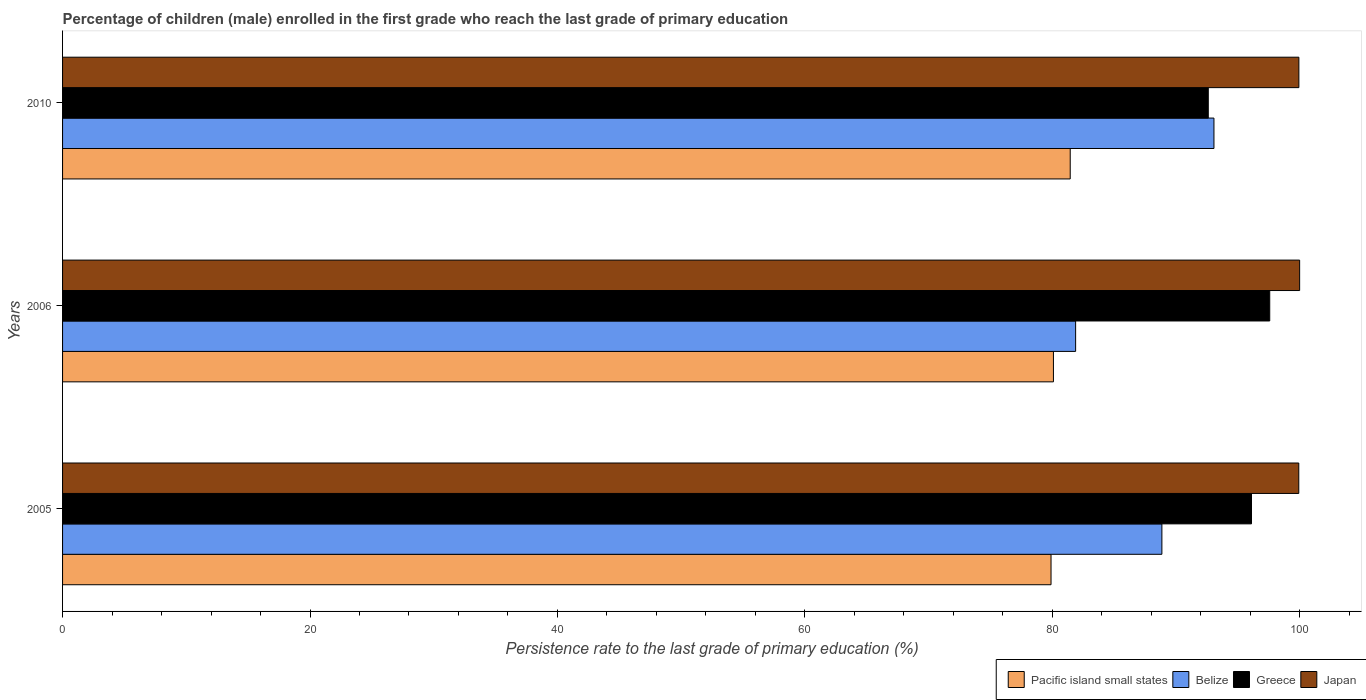How many different coloured bars are there?
Offer a terse response. 4. How many groups of bars are there?
Offer a terse response. 3. Are the number of bars on each tick of the Y-axis equal?
Make the answer very short. Yes. How many bars are there on the 2nd tick from the top?
Provide a short and direct response. 4. How many bars are there on the 1st tick from the bottom?
Your answer should be compact. 4. In how many cases, is the number of bars for a given year not equal to the number of legend labels?
Offer a very short reply. 0. What is the persistence rate of children in Greece in 2006?
Give a very brief answer. 97.57. Across all years, what is the maximum persistence rate of children in Japan?
Your answer should be very brief. 99.99. Across all years, what is the minimum persistence rate of children in Greece?
Offer a terse response. 92.6. In which year was the persistence rate of children in Pacific island small states maximum?
Give a very brief answer. 2010. What is the total persistence rate of children in Belize in the graph?
Your answer should be very brief. 263.8. What is the difference between the persistence rate of children in Japan in 2005 and that in 2010?
Your answer should be very brief. -0.01. What is the difference between the persistence rate of children in Pacific island small states in 2006 and the persistence rate of children in Japan in 2010?
Give a very brief answer. -19.84. What is the average persistence rate of children in Belize per year?
Make the answer very short. 87.93. In the year 2010, what is the difference between the persistence rate of children in Japan and persistence rate of children in Belize?
Give a very brief answer. 6.86. What is the ratio of the persistence rate of children in Japan in 2005 to that in 2006?
Provide a succinct answer. 1. Is the persistence rate of children in Pacific island small states in 2005 less than that in 2006?
Your answer should be very brief. Yes. Is the difference between the persistence rate of children in Japan in 2005 and 2006 greater than the difference between the persistence rate of children in Belize in 2005 and 2006?
Provide a succinct answer. No. What is the difference between the highest and the second highest persistence rate of children in Japan?
Keep it short and to the point. 0.06. What is the difference between the highest and the lowest persistence rate of children in Greece?
Your response must be concise. 4.97. Is the sum of the persistence rate of children in Pacific island small states in 2005 and 2006 greater than the maximum persistence rate of children in Belize across all years?
Provide a short and direct response. Yes. Is it the case that in every year, the sum of the persistence rate of children in Belize and persistence rate of children in Japan is greater than the sum of persistence rate of children in Greece and persistence rate of children in Pacific island small states?
Make the answer very short. Yes. What does the 1st bar from the top in 2006 represents?
Provide a succinct answer. Japan. What does the 3rd bar from the bottom in 2010 represents?
Your answer should be very brief. Greece. How many bars are there?
Your response must be concise. 12. Does the graph contain any zero values?
Keep it short and to the point. No. How are the legend labels stacked?
Make the answer very short. Horizontal. What is the title of the graph?
Your response must be concise. Percentage of children (male) enrolled in the first grade who reach the last grade of primary education. Does "Korea (Democratic)" appear as one of the legend labels in the graph?
Provide a short and direct response. No. What is the label or title of the X-axis?
Your response must be concise. Persistence rate to the last grade of primary education (%). What is the Persistence rate to the last grade of primary education (%) of Pacific island small states in 2005?
Ensure brevity in your answer.  79.89. What is the Persistence rate to the last grade of primary education (%) of Belize in 2005?
Ensure brevity in your answer.  88.85. What is the Persistence rate to the last grade of primary education (%) of Greece in 2005?
Your answer should be compact. 96.1. What is the Persistence rate to the last grade of primary education (%) of Japan in 2005?
Your response must be concise. 99.92. What is the Persistence rate to the last grade of primary education (%) of Pacific island small states in 2006?
Make the answer very short. 80.09. What is the Persistence rate to the last grade of primary education (%) in Belize in 2006?
Keep it short and to the point. 81.88. What is the Persistence rate to the last grade of primary education (%) of Greece in 2006?
Provide a succinct answer. 97.57. What is the Persistence rate to the last grade of primary education (%) in Japan in 2006?
Provide a short and direct response. 99.99. What is the Persistence rate to the last grade of primary education (%) in Pacific island small states in 2010?
Offer a terse response. 81.44. What is the Persistence rate to the last grade of primary education (%) in Belize in 2010?
Ensure brevity in your answer.  93.06. What is the Persistence rate to the last grade of primary education (%) in Greece in 2010?
Provide a succinct answer. 92.6. What is the Persistence rate to the last grade of primary education (%) of Japan in 2010?
Your answer should be very brief. 99.93. Across all years, what is the maximum Persistence rate to the last grade of primary education (%) of Pacific island small states?
Provide a succinct answer. 81.44. Across all years, what is the maximum Persistence rate to the last grade of primary education (%) in Belize?
Provide a succinct answer. 93.06. Across all years, what is the maximum Persistence rate to the last grade of primary education (%) in Greece?
Offer a terse response. 97.57. Across all years, what is the maximum Persistence rate to the last grade of primary education (%) of Japan?
Offer a terse response. 99.99. Across all years, what is the minimum Persistence rate to the last grade of primary education (%) in Pacific island small states?
Provide a succinct answer. 79.89. Across all years, what is the minimum Persistence rate to the last grade of primary education (%) of Belize?
Your response must be concise. 81.88. Across all years, what is the minimum Persistence rate to the last grade of primary education (%) in Greece?
Your response must be concise. 92.6. Across all years, what is the minimum Persistence rate to the last grade of primary education (%) in Japan?
Offer a terse response. 99.92. What is the total Persistence rate to the last grade of primary education (%) in Pacific island small states in the graph?
Offer a terse response. 241.43. What is the total Persistence rate to the last grade of primary education (%) of Belize in the graph?
Provide a short and direct response. 263.8. What is the total Persistence rate to the last grade of primary education (%) in Greece in the graph?
Ensure brevity in your answer.  286.27. What is the total Persistence rate to the last grade of primary education (%) of Japan in the graph?
Your response must be concise. 299.83. What is the difference between the Persistence rate to the last grade of primary education (%) of Pacific island small states in 2005 and that in 2006?
Provide a short and direct response. -0.19. What is the difference between the Persistence rate to the last grade of primary education (%) of Belize in 2005 and that in 2006?
Your answer should be compact. 6.97. What is the difference between the Persistence rate to the last grade of primary education (%) of Greece in 2005 and that in 2006?
Provide a succinct answer. -1.47. What is the difference between the Persistence rate to the last grade of primary education (%) in Japan in 2005 and that in 2006?
Keep it short and to the point. -0.07. What is the difference between the Persistence rate to the last grade of primary education (%) in Pacific island small states in 2005 and that in 2010?
Make the answer very short. -1.55. What is the difference between the Persistence rate to the last grade of primary education (%) of Belize in 2005 and that in 2010?
Make the answer very short. -4.21. What is the difference between the Persistence rate to the last grade of primary education (%) of Greece in 2005 and that in 2010?
Your answer should be very brief. 3.49. What is the difference between the Persistence rate to the last grade of primary education (%) of Japan in 2005 and that in 2010?
Provide a succinct answer. -0.01. What is the difference between the Persistence rate to the last grade of primary education (%) of Pacific island small states in 2006 and that in 2010?
Your response must be concise. -1.36. What is the difference between the Persistence rate to the last grade of primary education (%) in Belize in 2006 and that in 2010?
Your response must be concise. -11.18. What is the difference between the Persistence rate to the last grade of primary education (%) in Greece in 2006 and that in 2010?
Offer a terse response. 4.97. What is the difference between the Persistence rate to the last grade of primary education (%) of Japan in 2006 and that in 2010?
Offer a terse response. 0.06. What is the difference between the Persistence rate to the last grade of primary education (%) in Pacific island small states in 2005 and the Persistence rate to the last grade of primary education (%) in Belize in 2006?
Provide a succinct answer. -1.99. What is the difference between the Persistence rate to the last grade of primary education (%) in Pacific island small states in 2005 and the Persistence rate to the last grade of primary education (%) in Greece in 2006?
Provide a succinct answer. -17.68. What is the difference between the Persistence rate to the last grade of primary education (%) in Pacific island small states in 2005 and the Persistence rate to the last grade of primary education (%) in Japan in 2006?
Give a very brief answer. -20.09. What is the difference between the Persistence rate to the last grade of primary education (%) of Belize in 2005 and the Persistence rate to the last grade of primary education (%) of Greece in 2006?
Offer a very short reply. -8.72. What is the difference between the Persistence rate to the last grade of primary education (%) of Belize in 2005 and the Persistence rate to the last grade of primary education (%) of Japan in 2006?
Offer a terse response. -11.13. What is the difference between the Persistence rate to the last grade of primary education (%) of Greece in 2005 and the Persistence rate to the last grade of primary education (%) of Japan in 2006?
Ensure brevity in your answer.  -3.89. What is the difference between the Persistence rate to the last grade of primary education (%) of Pacific island small states in 2005 and the Persistence rate to the last grade of primary education (%) of Belize in 2010?
Your response must be concise. -13.17. What is the difference between the Persistence rate to the last grade of primary education (%) in Pacific island small states in 2005 and the Persistence rate to the last grade of primary education (%) in Greece in 2010?
Keep it short and to the point. -12.71. What is the difference between the Persistence rate to the last grade of primary education (%) of Pacific island small states in 2005 and the Persistence rate to the last grade of primary education (%) of Japan in 2010?
Keep it short and to the point. -20.03. What is the difference between the Persistence rate to the last grade of primary education (%) of Belize in 2005 and the Persistence rate to the last grade of primary education (%) of Greece in 2010?
Offer a very short reply. -3.75. What is the difference between the Persistence rate to the last grade of primary education (%) of Belize in 2005 and the Persistence rate to the last grade of primary education (%) of Japan in 2010?
Provide a short and direct response. -11.07. What is the difference between the Persistence rate to the last grade of primary education (%) of Greece in 2005 and the Persistence rate to the last grade of primary education (%) of Japan in 2010?
Ensure brevity in your answer.  -3.83. What is the difference between the Persistence rate to the last grade of primary education (%) of Pacific island small states in 2006 and the Persistence rate to the last grade of primary education (%) of Belize in 2010?
Offer a terse response. -12.97. What is the difference between the Persistence rate to the last grade of primary education (%) in Pacific island small states in 2006 and the Persistence rate to the last grade of primary education (%) in Greece in 2010?
Make the answer very short. -12.51. What is the difference between the Persistence rate to the last grade of primary education (%) in Pacific island small states in 2006 and the Persistence rate to the last grade of primary education (%) in Japan in 2010?
Provide a succinct answer. -19.84. What is the difference between the Persistence rate to the last grade of primary education (%) of Belize in 2006 and the Persistence rate to the last grade of primary education (%) of Greece in 2010?
Keep it short and to the point. -10.72. What is the difference between the Persistence rate to the last grade of primary education (%) in Belize in 2006 and the Persistence rate to the last grade of primary education (%) in Japan in 2010?
Provide a short and direct response. -18.04. What is the difference between the Persistence rate to the last grade of primary education (%) in Greece in 2006 and the Persistence rate to the last grade of primary education (%) in Japan in 2010?
Your answer should be very brief. -2.36. What is the average Persistence rate to the last grade of primary education (%) of Pacific island small states per year?
Your answer should be very brief. 80.48. What is the average Persistence rate to the last grade of primary education (%) in Belize per year?
Your response must be concise. 87.93. What is the average Persistence rate to the last grade of primary education (%) in Greece per year?
Your answer should be very brief. 95.42. What is the average Persistence rate to the last grade of primary education (%) in Japan per year?
Offer a very short reply. 99.94. In the year 2005, what is the difference between the Persistence rate to the last grade of primary education (%) in Pacific island small states and Persistence rate to the last grade of primary education (%) in Belize?
Keep it short and to the point. -8.96. In the year 2005, what is the difference between the Persistence rate to the last grade of primary education (%) in Pacific island small states and Persistence rate to the last grade of primary education (%) in Greece?
Provide a short and direct response. -16.2. In the year 2005, what is the difference between the Persistence rate to the last grade of primary education (%) of Pacific island small states and Persistence rate to the last grade of primary education (%) of Japan?
Your answer should be compact. -20.02. In the year 2005, what is the difference between the Persistence rate to the last grade of primary education (%) of Belize and Persistence rate to the last grade of primary education (%) of Greece?
Your answer should be very brief. -7.24. In the year 2005, what is the difference between the Persistence rate to the last grade of primary education (%) of Belize and Persistence rate to the last grade of primary education (%) of Japan?
Keep it short and to the point. -11.06. In the year 2005, what is the difference between the Persistence rate to the last grade of primary education (%) in Greece and Persistence rate to the last grade of primary education (%) in Japan?
Your answer should be very brief. -3.82. In the year 2006, what is the difference between the Persistence rate to the last grade of primary education (%) of Pacific island small states and Persistence rate to the last grade of primary education (%) of Belize?
Offer a very short reply. -1.79. In the year 2006, what is the difference between the Persistence rate to the last grade of primary education (%) of Pacific island small states and Persistence rate to the last grade of primary education (%) of Greece?
Your answer should be very brief. -17.48. In the year 2006, what is the difference between the Persistence rate to the last grade of primary education (%) of Pacific island small states and Persistence rate to the last grade of primary education (%) of Japan?
Keep it short and to the point. -19.9. In the year 2006, what is the difference between the Persistence rate to the last grade of primary education (%) in Belize and Persistence rate to the last grade of primary education (%) in Greece?
Provide a succinct answer. -15.69. In the year 2006, what is the difference between the Persistence rate to the last grade of primary education (%) in Belize and Persistence rate to the last grade of primary education (%) in Japan?
Your answer should be very brief. -18.11. In the year 2006, what is the difference between the Persistence rate to the last grade of primary education (%) of Greece and Persistence rate to the last grade of primary education (%) of Japan?
Offer a very short reply. -2.42. In the year 2010, what is the difference between the Persistence rate to the last grade of primary education (%) in Pacific island small states and Persistence rate to the last grade of primary education (%) in Belize?
Keep it short and to the point. -11.62. In the year 2010, what is the difference between the Persistence rate to the last grade of primary education (%) of Pacific island small states and Persistence rate to the last grade of primary education (%) of Greece?
Your response must be concise. -11.16. In the year 2010, what is the difference between the Persistence rate to the last grade of primary education (%) of Pacific island small states and Persistence rate to the last grade of primary education (%) of Japan?
Offer a very short reply. -18.48. In the year 2010, what is the difference between the Persistence rate to the last grade of primary education (%) in Belize and Persistence rate to the last grade of primary education (%) in Greece?
Make the answer very short. 0.46. In the year 2010, what is the difference between the Persistence rate to the last grade of primary education (%) of Belize and Persistence rate to the last grade of primary education (%) of Japan?
Provide a succinct answer. -6.86. In the year 2010, what is the difference between the Persistence rate to the last grade of primary education (%) of Greece and Persistence rate to the last grade of primary education (%) of Japan?
Give a very brief answer. -7.32. What is the ratio of the Persistence rate to the last grade of primary education (%) in Belize in 2005 to that in 2006?
Provide a short and direct response. 1.09. What is the ratio of the Persistence rate to the last grade of primary education (%) of Greece in 2005 to that in 2006?
Provide a short and direct response. 0.98. What is the ratio of the Persistence rate to the last grade of primary education (%) of Japan in 2005 to that in 2006?
Make the answer very short. 1. What is the ratio of the Persistence rate to the last grade of primary education (%) of Pacific island small states in 2005 to that in 2010?
Keep it short and to the point. 0.98. What is the ratio of the Persistence rate to the last grade of primary education (%) in Belize in 2005 to that in 2010?
Make the answer very short. 0.95. What is the ratio of the Persistence rate to the last grade of primary education (%) in Greece in 2005 to that in 2010?
Your response must be concise. 1.04. What is the ratio of the Persistence rate to the last grade of primary education (%) of Pacific island small states in 2006 to that in 2010?
Provide a succinct answer. 0.98. What is the ratio of the Persistence rate to the last grade of primary education (%) of Belize in 2006 to that in 2010?
Ensure brevity in your answer.  0.88. What is the ratio of the Persistence rate to the last grade of primary education (%) in Greece in 2006 to that in 2010?
Offer a terse response. 1.05. What is the ratio of the Persistence rate to the last grade of primary education (%) of Japan in 2006 to that in 2010?
Your answer should be compact. 1. What is the difference between the highest and the second highest Persistence rate to the last grade of primary education (%) in Pacific island small states?
Ensure brevity in your answer.  1.36. What is the difference between the highest and the second highest Persistence rate to the last grade of primary education (%) in Belize?
Your response must be concise. 4.21. What is the difference between the highest and the second highest Persistence rate to the last grade of primary education (%) in Greece?
Give a very brief answer. 1.47. What is the difference between the highest and the second highest Persistence rate to the last grade of primary education (%) of Japan?
Ensure brevity in your answer.  0.06. What is the difference between the highest and the lowest Persistence rate to the last grade of primary education (%) in Pacific island small states?
Keep it short and to the point. 1.55. What is the difference between the highest and the lowest Persistence rate to the last grade of primary education (%) in Belize?
Offer a very short reply. 11.18. What is the difference between the highest and the lowest Persistence rate to the last grade of primary education (%) in Greece?
Your answer should be compact. 4.97. What is the difference between the highest and the lowest Persistence rate to the last grade of primary education (%) of Japan?
Provide a short and direct response. 0.07. 